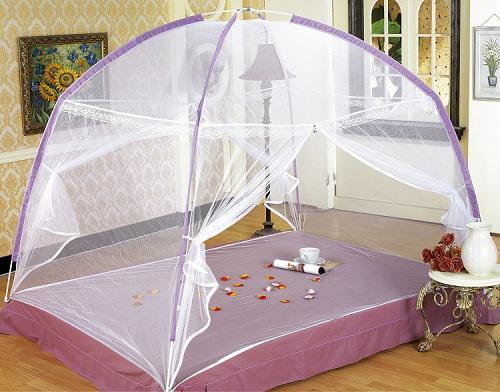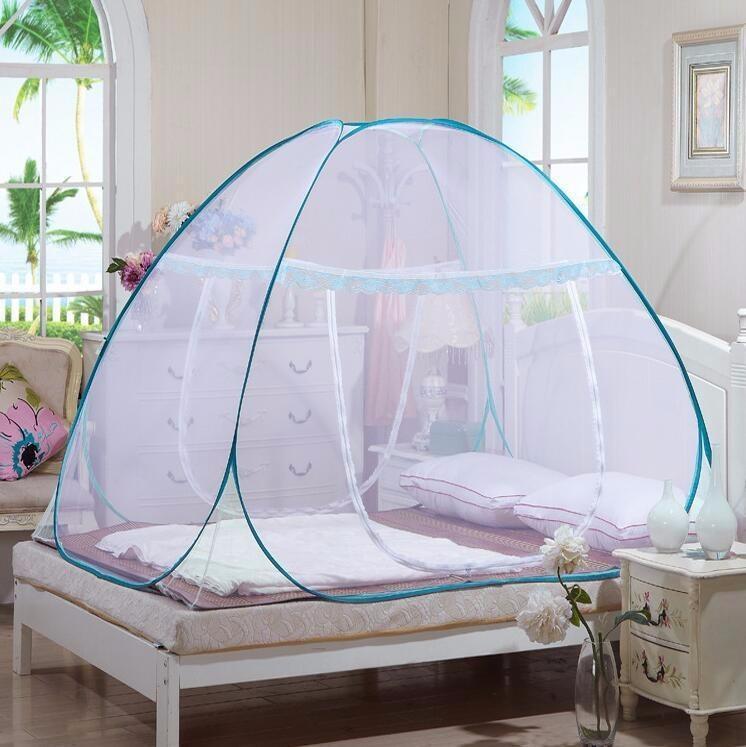The first image is the image on the left, the second image is the image on the right. Given the left and right images, does the statement "There are two canopies, one tent and one hanging from the ceiling." hold true? Answer yes or no. No. 